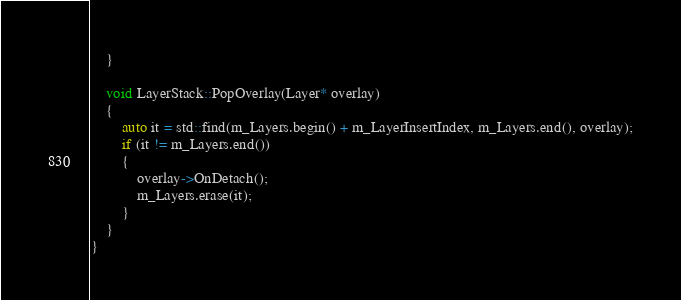Convert code to text. <code><loc_0><loc_0><loc_500><loc_500><_C++_>	}

	void LayerStack::PopOverlay(Layer* overlay)
	{
		auto it = std::find(m_Layers.begin() + m_LayerInsertIndex, m_Layers.end(), overlay);
		if (it != m_Layers.end())
		{
			overlay->OnDetach();
			m_Layers.erase(it);
		}
	}
}</code> 